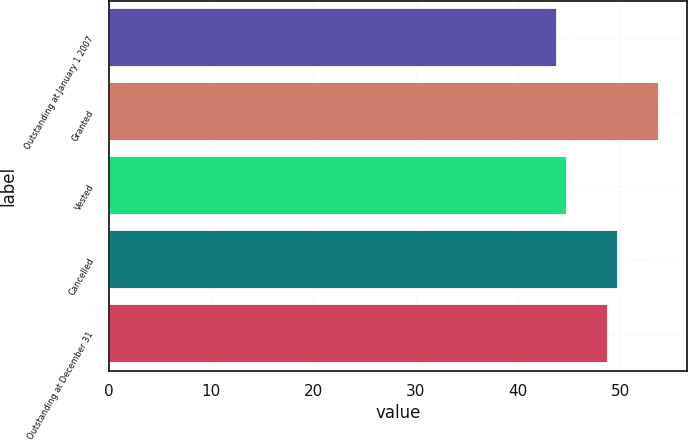<chart> <loc_0><loc_0><loc_500><loc_500><bar_chart><fcel>Outstanding at January 1 2007<fcel>Granted<fcel>Vested<fcel>Cancelled<fcel>Outstanding at December 31<nl><fcel>43.85<fcel>53.82<fcel>44.85<fcel>49.8<fcel>48.8<nl></chart> 